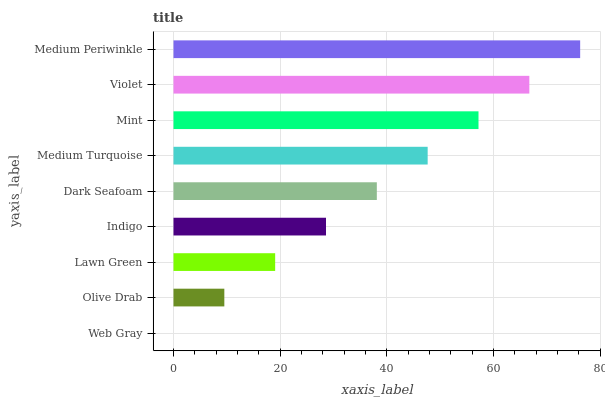Is Web Gray the minimum?
Answer yes or no. Yes. Is Medium Periwinkle the maximum?
Answer yes or no. Yes. Is Olive Drab the minimum?
Answer yes or no. No. Is Olive Drab the maximum?
Answer yes or no. No. Is Olive Drab greater than Web Gray?
Answer yes or no. Yes. Is Web Gray less than Olive Drab?
Answer yes or no. Yes. Is Web Gray greater than Olive Drab?
Answer yes or no. No. Is Olive Drab less than Web Gray?
Answer yes or no. No. Is Dark Seafoam the high median?
Answer yes or no. Yes. Is Dark Seafoam the low median?
Answer yes or no. Yes. Is Mint the high median?
Answer yes or no. No. Is Olive Drab the low median?
Answer yes or no. No. 